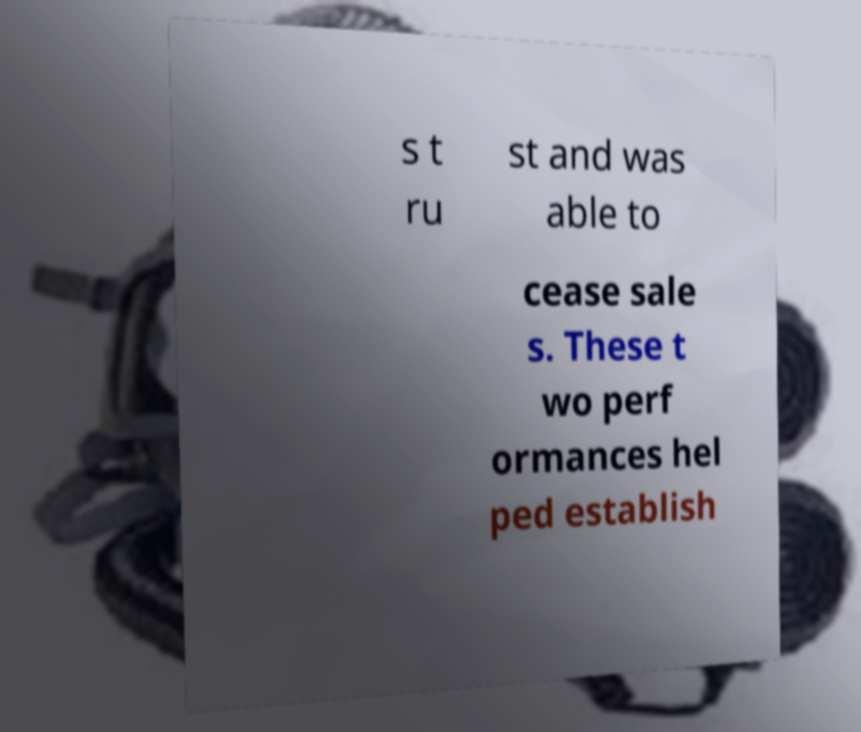Can you accurately transcribe the text from the provided image for me? s t ru st and was able to cease sale s. These t wo perf ormances hel ped establish 